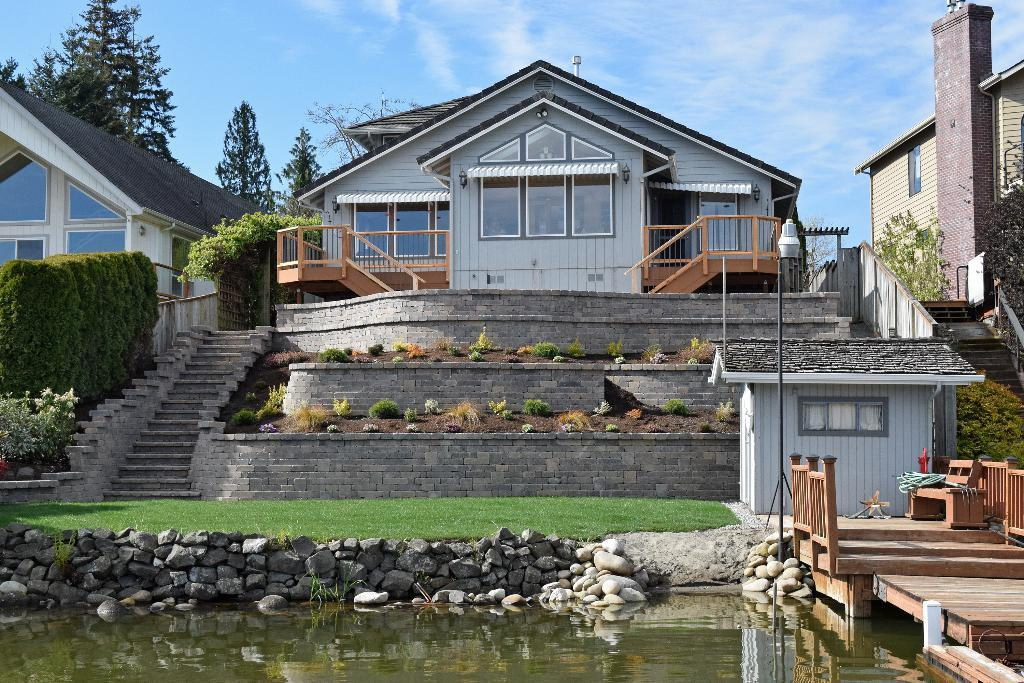What is one of the main elements in the image? There is water in the image. What other objects can be seen in the image? There are stones, houses, grass, plants, and a wall in the image. What type of vegetation is present in the image? There are plants and trees in the image. What part of the natural environment is visible in the image? The sky is visible in the background of the image. What type of skin is visible on the houses in the image? There is no skin visible on the houses in the image; they are made of a solid material, such as brick or wood. What type of apparel is worn by the trees in the image? There are no trees wearing apparel in the image; trees do not wear clothing. 